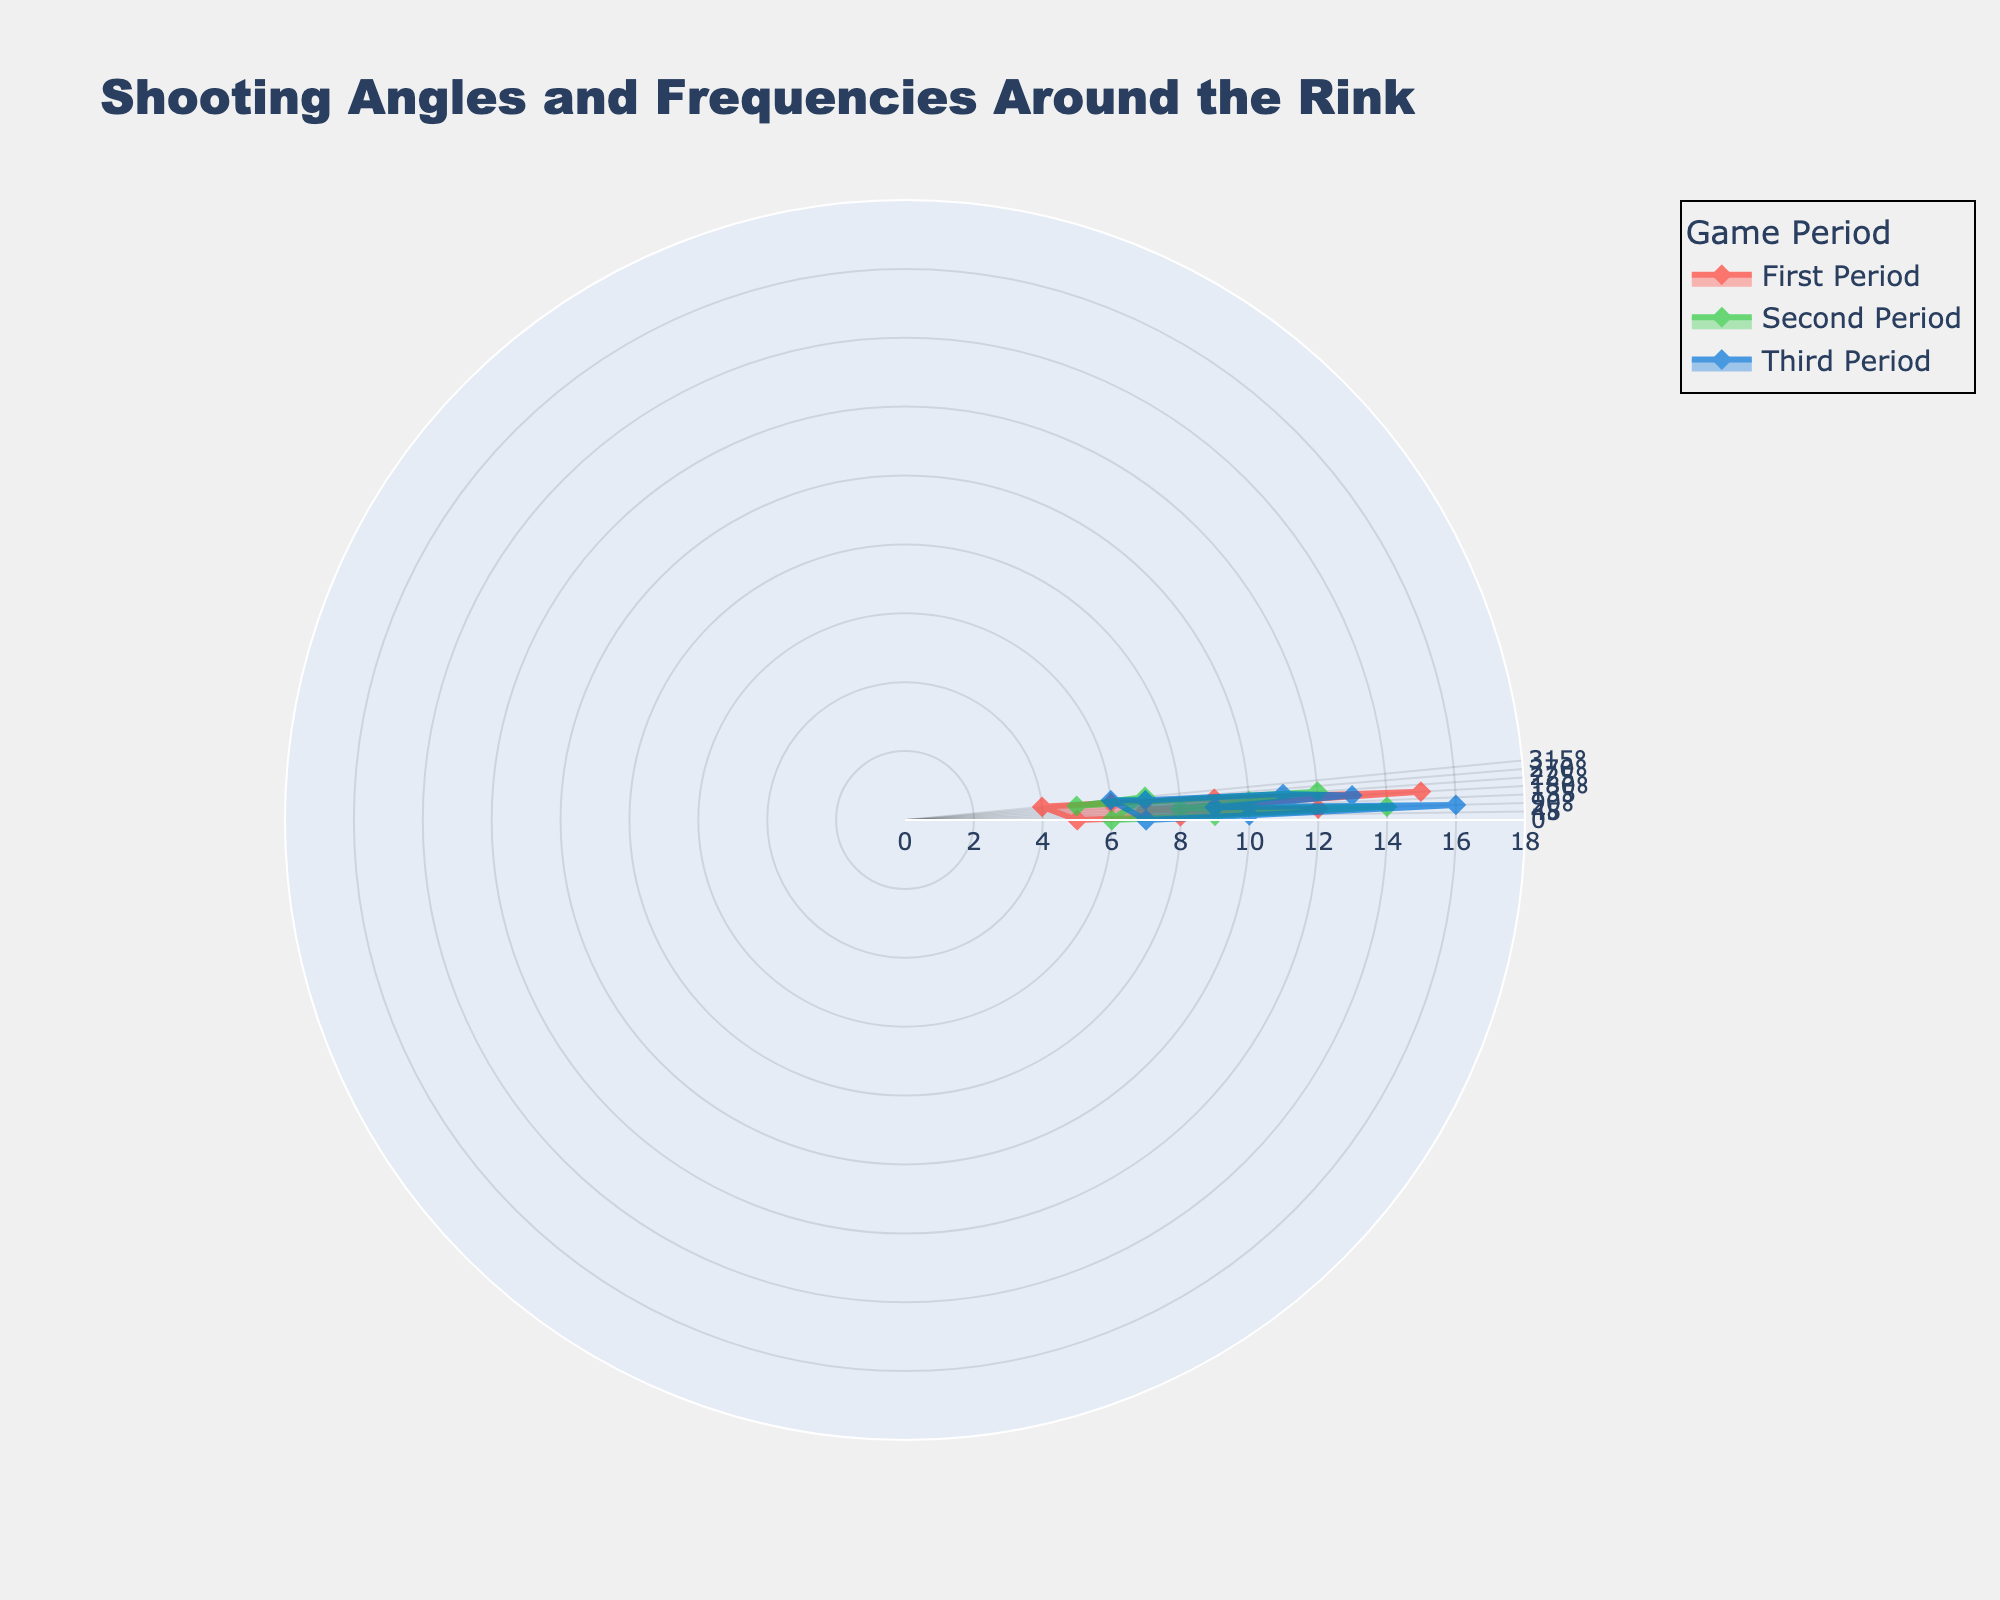What's the title of the figure? The title is usually at the top of the figure, clearly indicating what the plot is about.
Answer: Shooting Angles and Frequencies Around the Rink How many game periods are represented in the figure? By observing the legend or the different lines/colors in the plot, we can identify the number of unique periods.
Answer: Three periods At which angle was the highest frequency recorded? We look for the maximum radial distance from the center and note its corresponding angle.
Answer: 90° What is the frequency of shooting at a 180° angle during the second period? Locate the plot line or marker for the second period and check the value at the 180° angle.
Answer: 10 Which period has the lowest frequency at the 270° angle, and what is that frequency? Compare the radial distance at the 270° angle for all periods and note the smallest value.
Answer: Second period, 5 What's the average frequency of shooting at the 135° angle across all periods? Sum the frequencies at 135° for each period and divide by the number of periods. (7 + 8 + 9) / 3 = 8
Answer: 8 Between the first and third periods, which one has a greater shooting frequency at the 45° angle, and what is the difference? Compare the values at 45° for the first and third periods. The difference is calculated as \(10 - 8 = 2\).
Answer: Third period, 2 Does the shooting frequency generally increase, decrease, or stay consistent from the first to the third period? Observe the trend in frequencies from the first to the third period at several angles (especially peaks and valleys).
Answer: Generally increases What's the sum of the frequencies at the 225° angle for all periods? Add the frequencies at 225° from all periods: \(9 + 12 + 11\).
Answer: 32 Which period shows the most variation in shooting frequency across all angles? Look for the period with the widest range between the highest and lowest frequencies. The third period ranges from 6 to 16, which is the highest variation.
Answer: Third period 